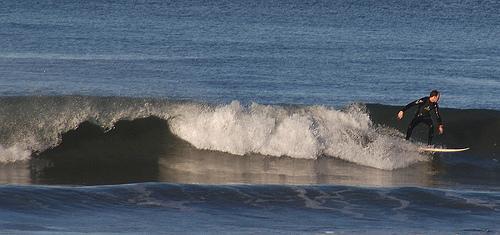How many people are there?
Give a very brief answer. 1. 